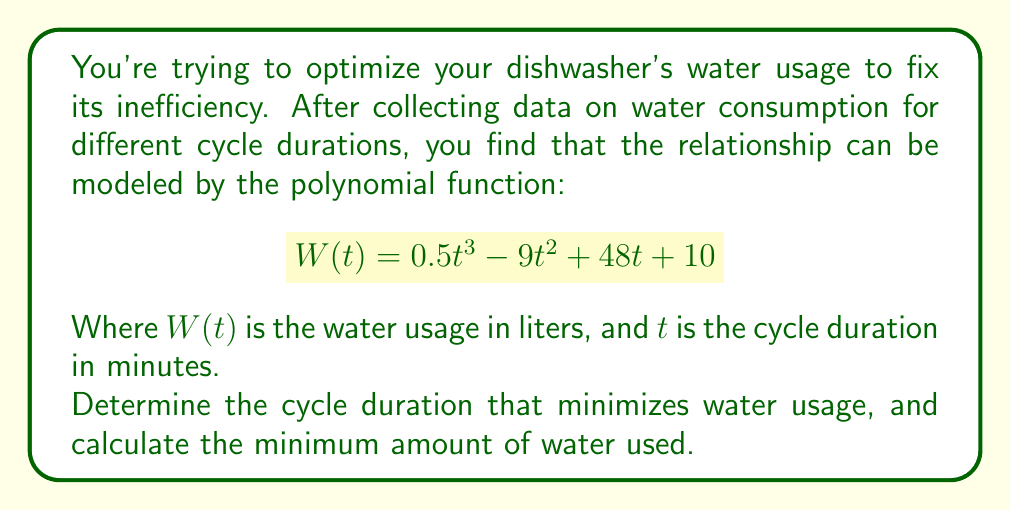Could you help me with this problem? To find the minimum water usage, we need to find the minimum point of the polynomial function. This occurs where the derivative of the function equals zero.

1. Find the derivative of $W(t)$:
   $$W'(t) = 1.5t^2 - 18t + 48$$

2. Set the derivative equal to zero and solve for $t$:
   $$1.5t^2 - 18t + 48 = 0$$

3. This is a quadratic equation. We can solve it using the quadratic formula:
   $$t = \frac{-b \pm \sqrt{b^2 - 4ac}}{2a}$$
   Where $a = 1.5$, $b = -18$, and $c = 48$

4. Plugging in the values:
   $$t = \frac{18 \pm \sqrt{(-18)^2 - 4(1.5)(48)}}{2(1.5)}$$
   $$t = \frac{18 \pm \sqrt{324 - 288}}{3}$$
   $$t = \frac{18 \pm \sqrt{36}}{3}$$
   $$t = \frac{18 \pm 6}{3}$$

5. This gives us two solutions:
   $$t_1 = \frac{18 + 6}{3} = 8 \text{ minutes}$$
   $$t_2 = \frac{18 - 6}{3} = 4 \text{ minutes}$$

6. To determine which solution gives the minimum, we can check the second derivative:
   $$W''(t) = 3t - 18$$
   At $t = 8$, $W''(8) = 6 > 0$, indicating a minimum.
   At $t = 4$, $W''(4) = -6 < 0$, indicating a maximum.

7. Therefore, the minimum occurs at $t = 8$ minutes.

8. Calculate the minimum water usage by plugging $t = 8$ into the original function:
   $$W(8) = 0.5(8)^3 - 9(8)^2 + 48(8) + 10$$
   $$W(8) = 0.5(512) - 9(64) + 384 + 10$$
   $$W(8) = 256 - 576 + 384 + 10$$
   $$W(8) = 74 \text{ liters}$$
Answer: The cycle duration that minimizes water usage is 8 minutes, and the minimum amount of water used is 74 liters. 